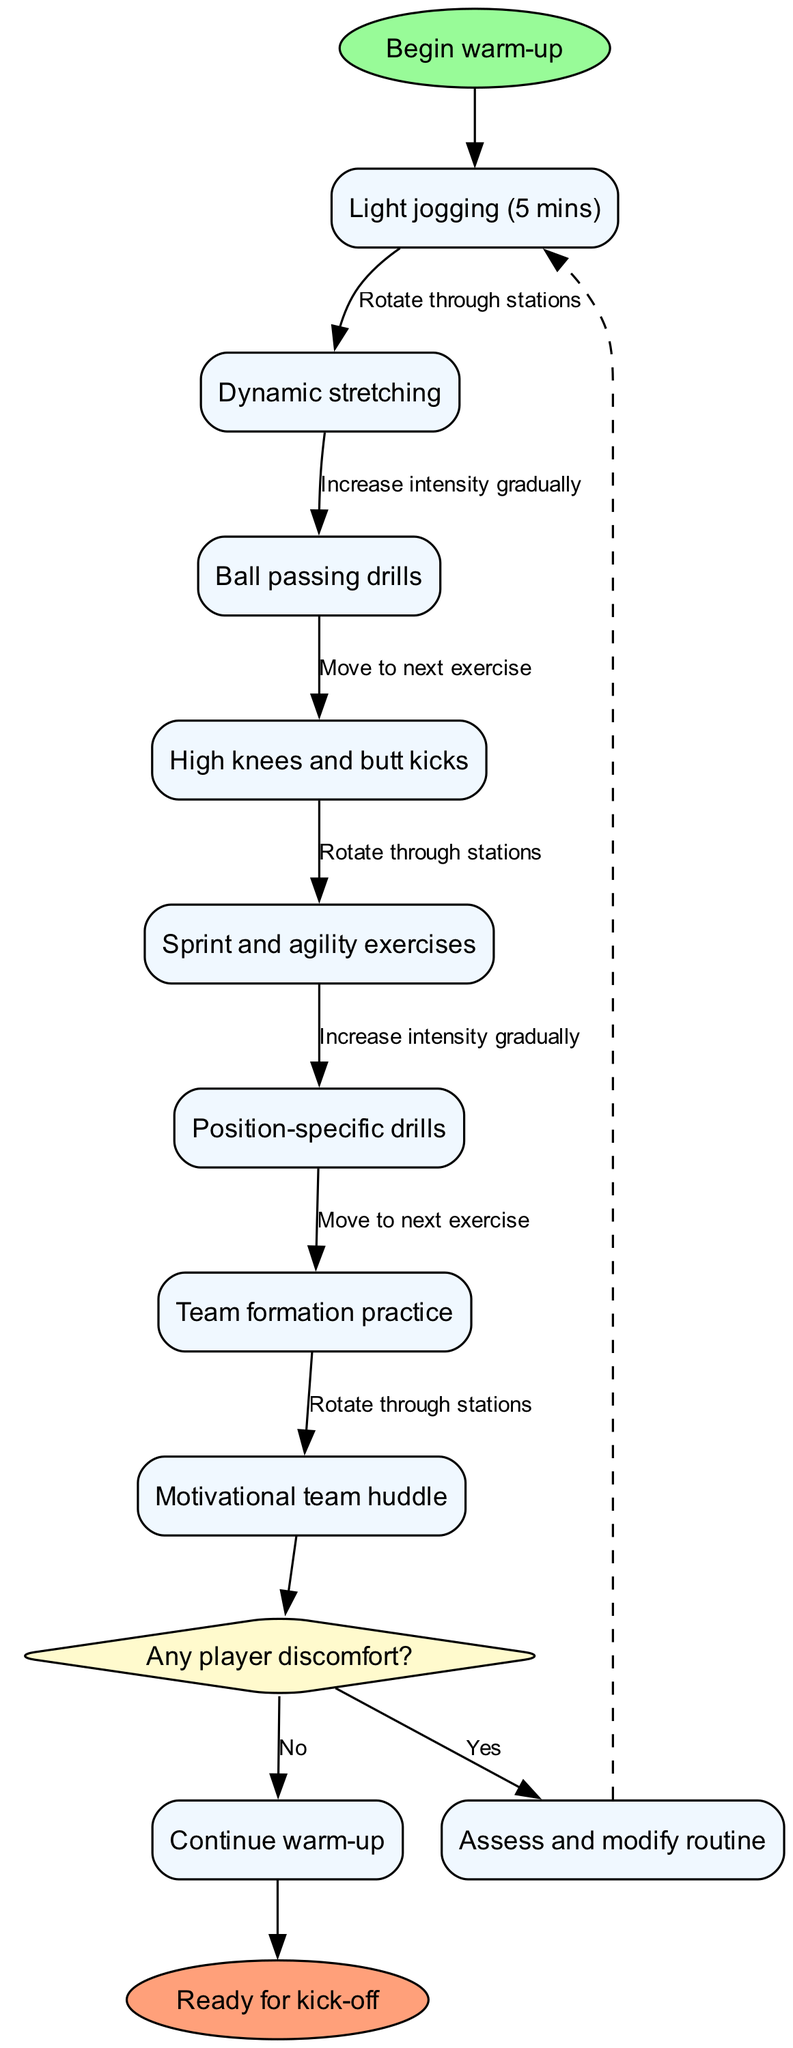What is the first activity in the warm-up routine? The first activity is listed in the diagram as "Light jogging (5 mins)," which is directly connected to the start node.
Answer: Light jogging (5 mins) How many activities are in the warm-up routine? The diagram lists a total of 8 activities, which can be counted by reviewing the activities section.
Answer: 8 What happens if a player experiences discomfort during the warm-up? The diagram indicates that if there is discomfort, the routine requires an assessment and modification, leading to the "Assess and modify routine" node.
Answer: Assess and modify routine What is the last node connected to the decision node? The last node connected to the decision node is labeled "Ready for kick-off," indicating the conclusion of the warm-up process if no player discomfort is present.
Answer: Ready for kick-off Which exercise follows "High knees and butt kicks"? The sequence shows that after "High knees and butt kicks," the next exercise is "Sprint and agility exercises," as indicated by the flow of activities.
Answer: Sprint and agility exercises What type of node is used to represent the decision regarding player discomfort? The decision regarding player discomfort is represented as a diamond-shaped node, a common convention in diagrams to indicate decision points.
Answer: Diamond What edge label connects "Position-specific drills" to "Team formation practice"? The edge label connecting these two nodes is "Move to next exercise," indicating the transition from one activity to the next in the routine.
Answer: Move to next exercise If player discomfort is reported, where do they go next in the flow? If discomfort is reported, the flow leads to the "Assess and modify routine" node, indicating that the warm-up will be adjusted as needed before continuing.
Answer: Assess and modify routine 